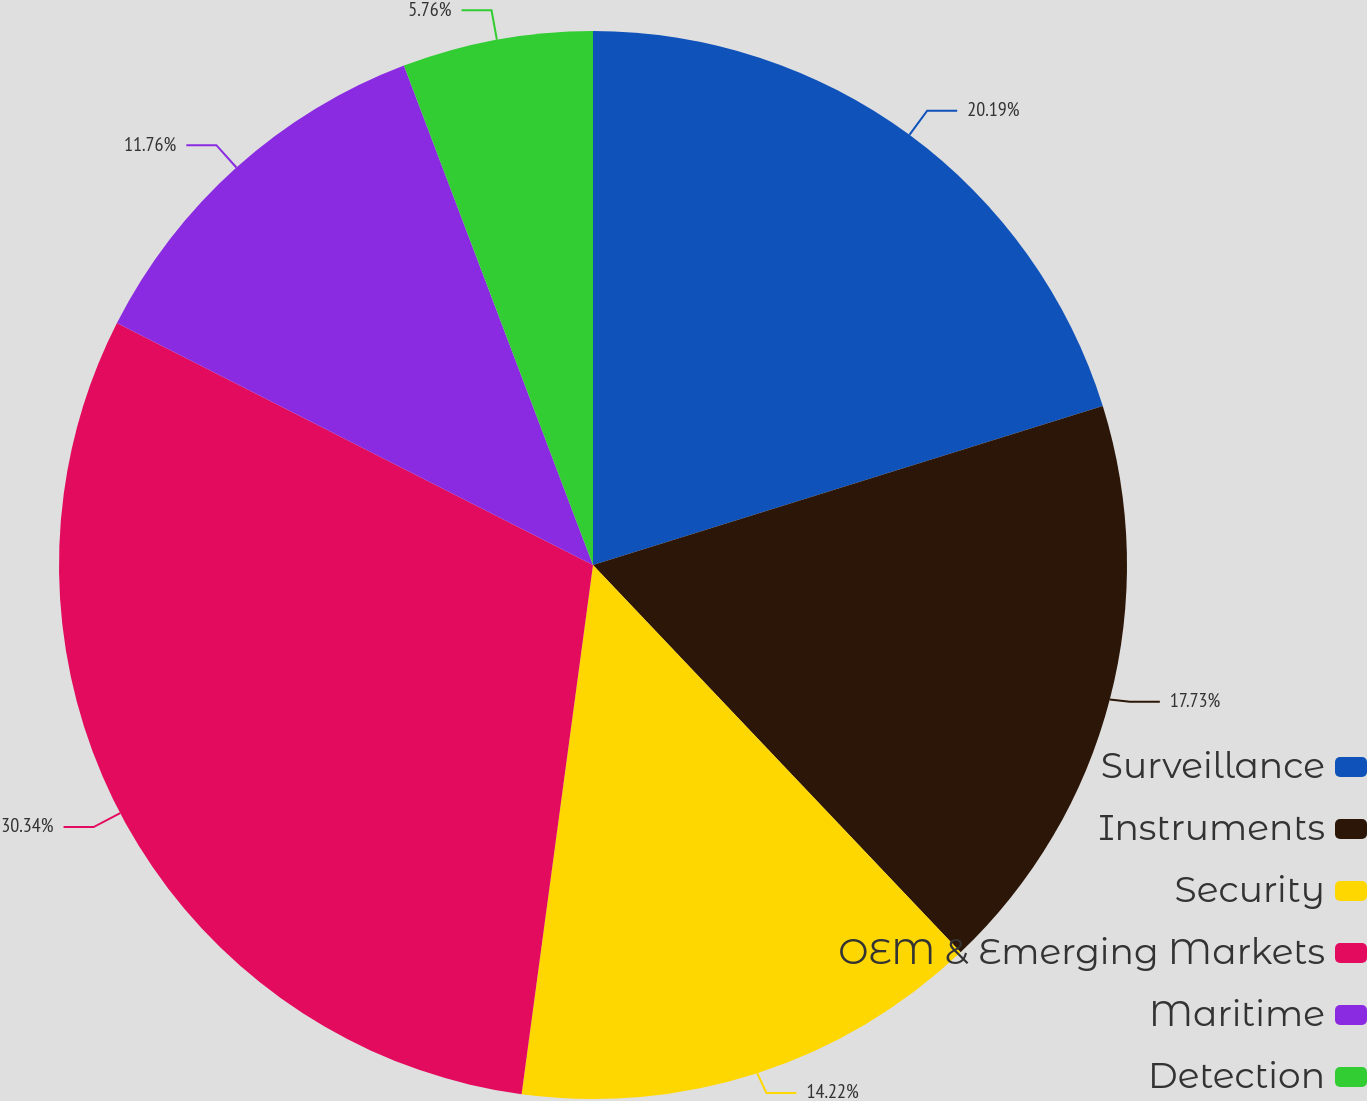Convert chart. <chart><loc_0><loc_0><loc_500><loc_500><pie_chart><fcel>Surveillance<fcel>Instruments<fcel>Security<fcel>OEM & Emerging Markets<fcel>Maritime<fcel>Detection<nl><fcel>20.19%<fcel>17.73%<fcel>14.22%<fcel>30.35%<fcel>11.76%<fcel>5.76%<nl></chart> 